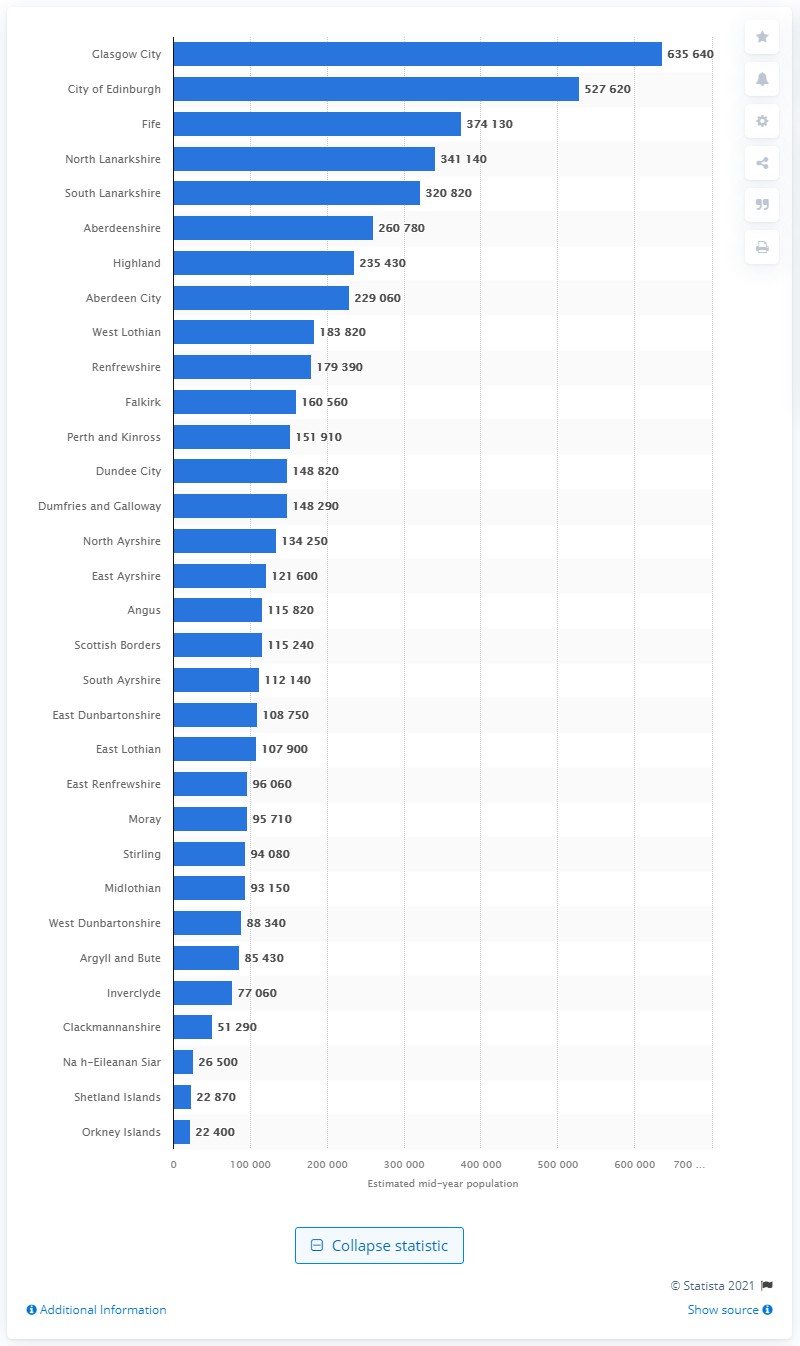Give some essential details in this illustration. In the year 2020, the population of Glasgow was estimated to be approximately 635,640 people. In Fife, there are approximately 374,130 people residing. 